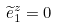<formula> <loc_0><loc_0><loc_500><loc_500>\widetilde { e } _ { 1 } ^ { z } = 0</formula> 